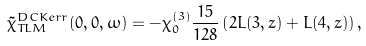Convert formula to latex. <formula><loc_0><loc_0><loc_500><loc_500>\tilde { \chi } ^ { D C K e r r } _ { T L M } ( 0 , 0 , \omega ) & = - \chi _ { 0 } ^ { ( 3 ) } \frac { 1 5 } { 1 2 8 } \left ( 2 L ( 3 , z ) + L ( 4 , z ) \right ) ,</formula> 